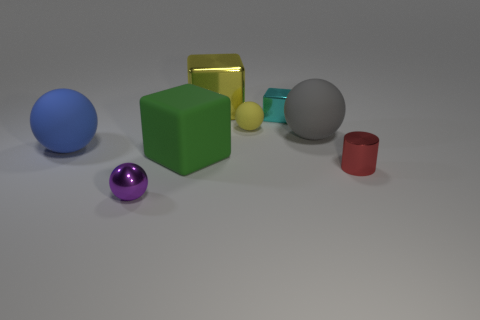Subtract all tiny purple balls. How many balls are left? 3 Subtract all cyan cubes. How many cubes are left? 2 Subtract all cylinders. How many objects are left? 7 Subtract all brown cylinders. How many yellow cubes are left? 1 Subtract all large cyan rubber cubes. Subtract all big blue rubber balls. How many objects are left? 7 Add 2 red cylinders. How many red cylinders are left? 3 Add 8 cyan cubes. How many cyan cubes exist? 9 Add 1 large blue rubber objects. How many objects exist? 9 Subtract 0 gray blocks. How many objects are left? 8 Subtract 1 balls. How many balls are left? 3 